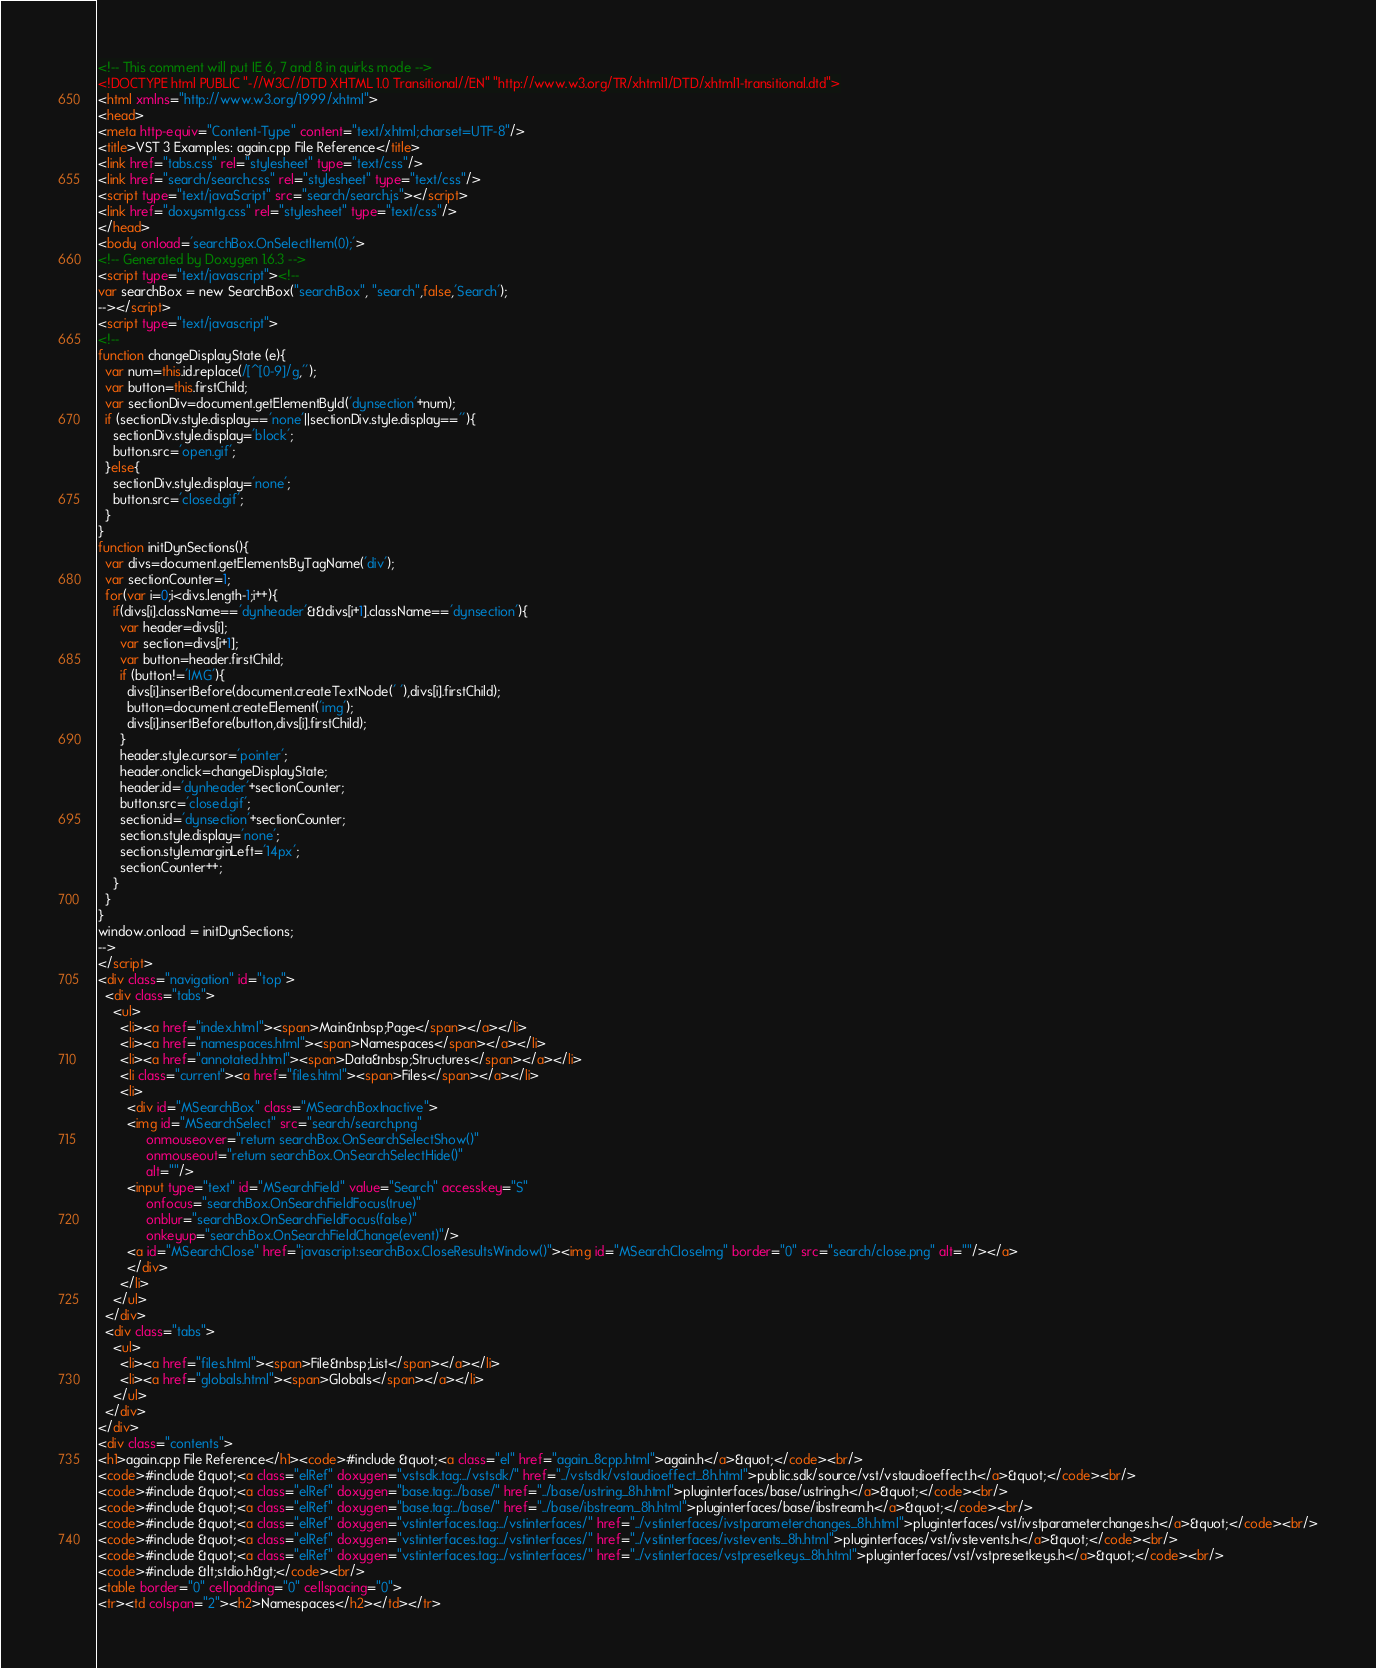<code> <loc_0><loc_0><loc_500><loc_500><_HTML_><!-- This comment will put IE 6, 7 and 8 in quirks mode -->
<!DOCTYPE html PUBLIC "-//W3C//DTD XHTML 1.0 Transitional//EN" "http://www.w3.org/TR/xhtml1/DTD/xhtml1-transitional.dtd">
<html xmlns="http://www.w3.org/1999/xhtml">
<head>
<meta http-equiv="Content-Type" content="text/xhtml;charset=UTF-8"/>
<title>VST 3 Examples: again.cpp File Reference</title>
<link href="tabs.css" rel="stylesheet" type="text/css"/>
<link href="search/search.css" rel="stylesheet" type="text/css"/>
<script type="text/javaScript" src="search/search.js"></script>
<link href="doxysmtg.css" rel="stylesheet" type="text/css"/>
</head>
<body onload='searchBox.OnSelectItem(0);'>
<!-- Generated by Doxygen 1.6.3 -->
<script type="text/javascript"><!--
var searchBox = new SearchBox("searchBox", "search",false,'Search');
--></script>
<script type="text/javascript">
<!--
function changeDisplayState (e){
  var num=this.id.replace(/[^[0-9]/g,'');
  var button=this.firstChild;
  var sectionDiv=document.getElementById('dynsection'+num);
  if (sectionDiv.style.display=='none'||sectionDiv.style.display==''){
    sectionDiv.style.display='block';
    button.src='open.gif';
  }else{
    sectionDiv.style.display='none';
    button.src='closed.gif';
  }
}
function initDynSections(){
  var divs=document.getElementsByTagName('div');
  var sectionCounter=1;
  for(var i=0;i<divs.length-1;i++){
    if(divs[i].className=='dynheader'&&divs[i+1].className=='dynsection'){
      var header=divs[i];
      var section=divs[i+1];
      var button=header.firstChild;
      if (button!='IMG'){
        divs[i].insertBefore(document.createTextNode(' '),divs[i].firstChild);
        button=document.createElement('img');
        divs[i].insertBefore(button,divs[i].firstChild);
      }
      header.style.cursor='pointer';
      header.onclick=changeDisplayState;
      header.id='dynheader'+sectionCounter;
      button.src='closed.gif';
      section.id='dynsection'+sectionCounter;
      section.style.display='none';
      section.style.marginLeft='14px';
      sectionCounter++;
    }
  }
}
window.onload = initDynSections;
-->
</script>
<div class="navigation" id="top">
  <div class="tabs">
    <ul>
      <li><a href="index.html"><span>Main&nbsp;Page</span></a></li>
      <li><a href="namespaces.html"><span>Namespaces</span></a></li>
      <li><a href="annotated.html"><span>Data&nbsp;Structures</span></a></li>
      <li class="current"><a href="files.html"><span>Files</span></a></li>
      <li>
        <div id="MSearchBox" class="MSearchBoxInactive">
        <img id="MSearchSelect" src="search/search.png"
             onmouseover="return searchBox.OnSearchSelectShow()"
             onmouseout="return searchBox.OnSearchSelectHide()"
             alt=""/>
        <input type="text" id="MSearchField" value="Search" accesskey="S"
             onfocus="searchBox.OnSearchFieldFocus(true)" 
             onblur="searchBox.OnSearchFieldFocus(false)" 
             onkeyup="searchBox.OnSearchFieldChange(event)"/>
        <a id="MSearchClose" href="javascript:searchBox.CloseResultsWindow()"><img id="MSearchCloseImg" border="0" src="search/close.png" alt=""/></a>
        </div>
      </li>
    </ul>
  </div>
  <div class="tabs">
    <ul>
      <li><a href="files.html"><span>File&nbsp;List</span></a></li>
      <li><a href="globals.html"><span>Globals</span></a></li>
    </ul>
  </div>
</div>
<div class="contents">
<h1>again.cpp File Reference</h1><code>#include &quot;<a class="el" href="again_8cpp.html">again.h</a>&quot;</code><br/>
<code>#include &quot;<a class="elRef" doxygen="vstsdk.tag:../vstsdk/" href="../vstsdk/vstaudioeffect_8h.html">public.sdk/source/vst/vstaudioeffect.h</a>&quot;</code><br/>
<code>#include &quot;<a class="elRef" doxygen="base.tag:../base/" href="../base/ustring_8h.html">pluginterfaces/base/ustring.h</a>&quot;</code><br/>
<code>#include &quot;<a class="elRef" doxygen="base.tag:../base/" href="../base/ibstream_8h.html">pluginterfaces/base/ibstream.h</a>&quot;</code><br/>
<code>#include &quot;<a class="elRef" doxygen="vstinterfaces.tag:../vstinterfaces/" href="../vstinterfaces/ivstparameterchanges_8h.html">pluginterfaces/vst/ivstparameterchanges.h</a>&quot;</code><br/>
<code>#include &quot;<a class="elRef" doxygen="vstinterfaces.tag:../vstinterfaces/" href="../vstinterfaces/ivstevents_8h.html">pluginterfaces/vst/ivstevents.h</a>&quot;</code><br/>
<code>#include &quot;<a class="elRef" doxygen="vstinterfaces.tag:../vstinterfaces/" href="../vstinterfaces/vstpresetkeys_8h.html">pluginterfaces/vst/vstpresetkeys.h</a>&quot;</code><br/>
<code>#include &lt;stdio.h&gt;</code><br/>
<table border="0" cellpadding="0" cellspacing="0">
<tr><td colspan="2"><h2>Namespaces</h2></td></tr></code> 